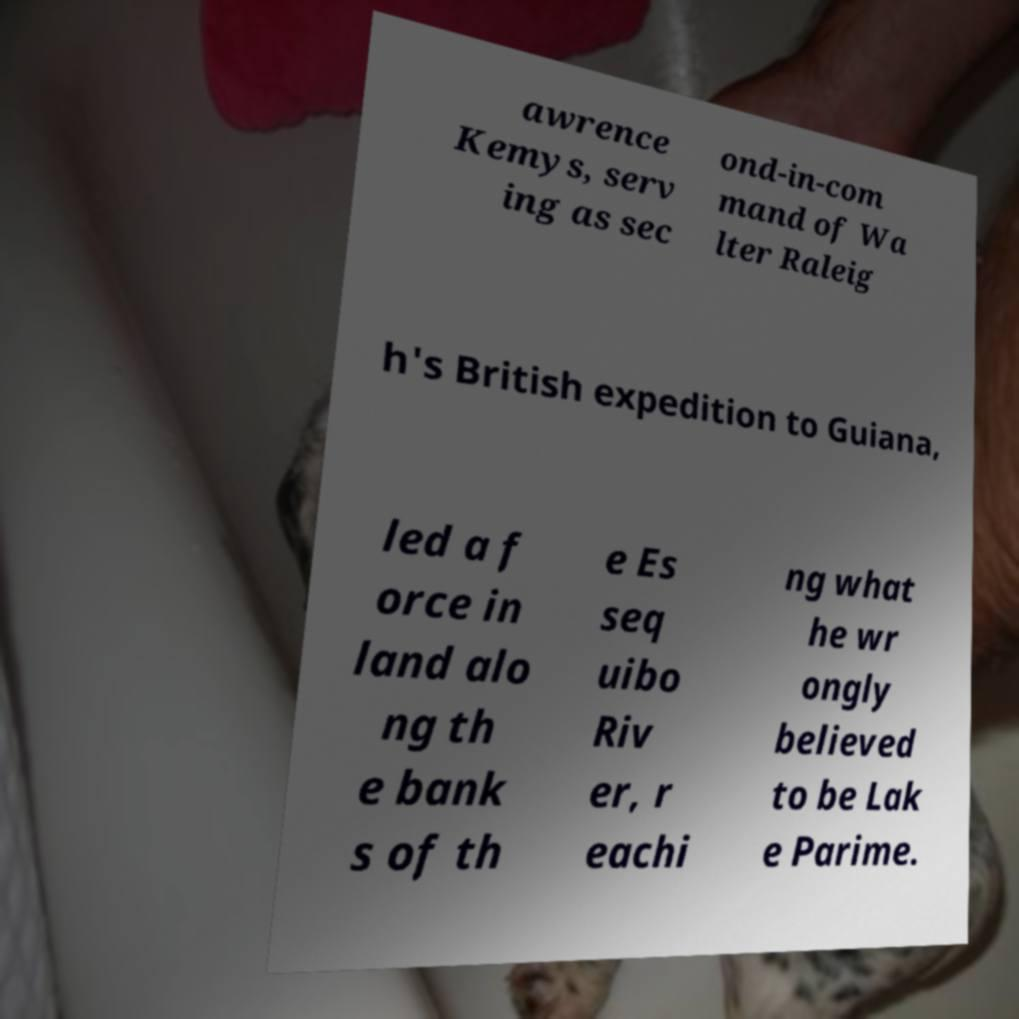Can you read and provide the text displayed in the image?This photo seems to have some interesting text. Can you extract and type it out for me? awrence Kemys, serv ing as sec ond-in-com mand of Wa lter Raleig h's British expedition to Guiana, led a f orce in land alo ng th e bank s of th e Es seq uibo Riv er, r eachi ng what he wr ongly believed to be Lak e Parime. 